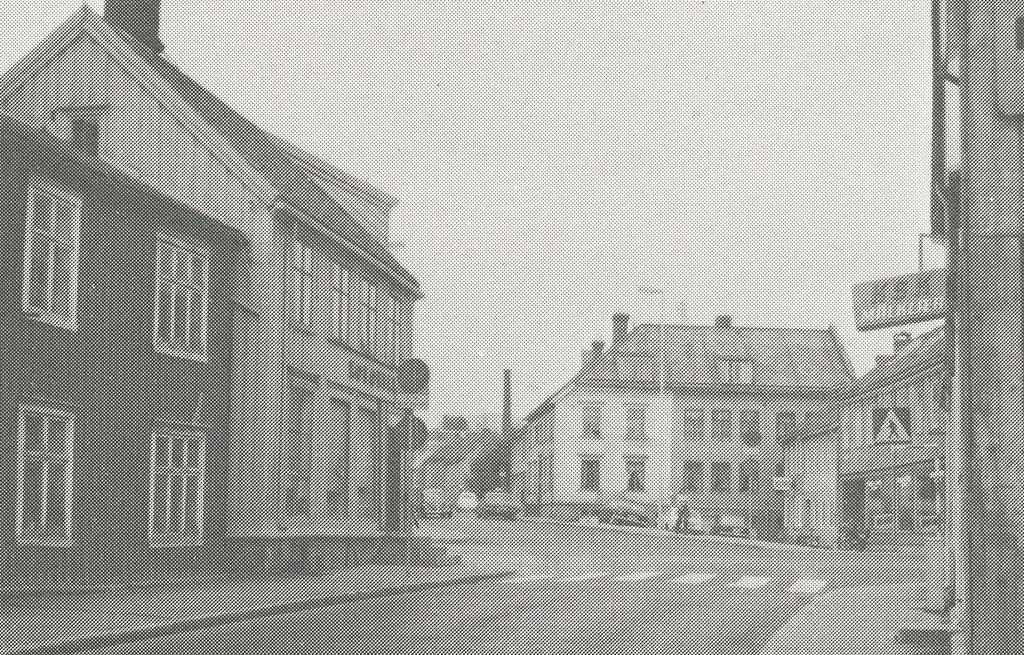What does the sign on the right say?
Make the answer very short. Ksk. 